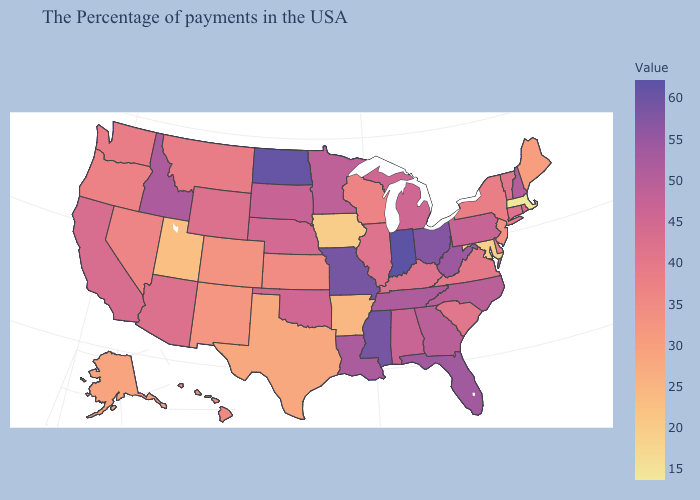Among the states that border Washington , does Oregon have the lowest value?
Write a very short answer. Yes. Which states hav the highest value in the South?
Keep it brief. Mississippi. Which states hav the highest value in the Northeast?
Keep it brief. New Hampshire. Does Idaho have the highest value in the West?
Be succinct. Yes. Does Indiana have the highest value in the USA?
Give a very brief answer. Yes. Which states hav the highest value in the South?
Concise answer only. Mississippi. Does South Dakota have the lowest value in the MidWest?
Short answer required. No. Among the states that border Pennsylvania , which have the highest value?
Concise answer only. Ohio. Which states have the highest value in the USA?
Concise answer only. Indiana. Among the states that border Delaware , which have the highest value?
Concise answer only. Pennsylvania. 